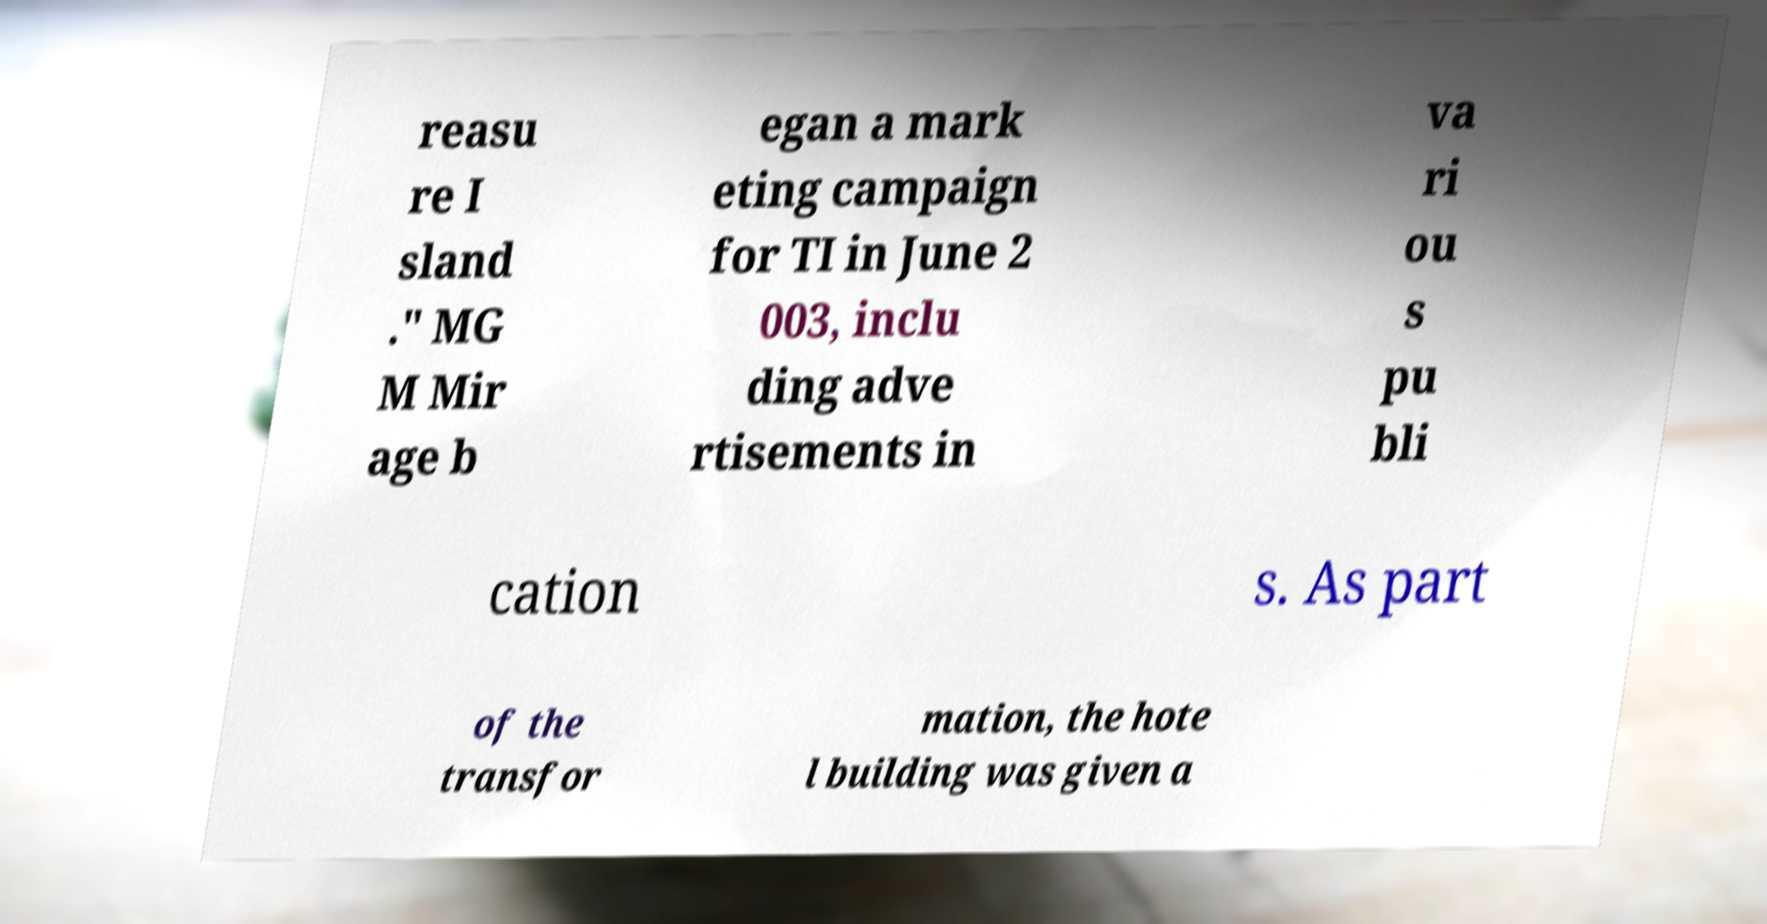Can you read and provide the text displayed in the image?This photo seems to have some interesting text. Can you extract and type it out for me? reasu re I sland ." MG M Mir age b egan a mark eting campaign for TI in June 2 003, inclu ding adve rtisements in va ri ou s pu bli cation s. As part of the transfor mation, the hote l building was given a 